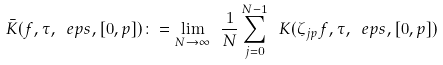Convert formula to latex. <formula><loc_0><loc_0><loc_500><loc_500>\bar { K } ( f , \tau , \ e p s , [ 0 , p ] ) \colon = \lim _ { N \to \infty } \ \frac { 1 } { N } \sum _ { j = 0 } ^ { N - 1 } \ K ( \zeta _ { j p } f , \tau , \ e p s , [ 0 , p ] )</formula> 